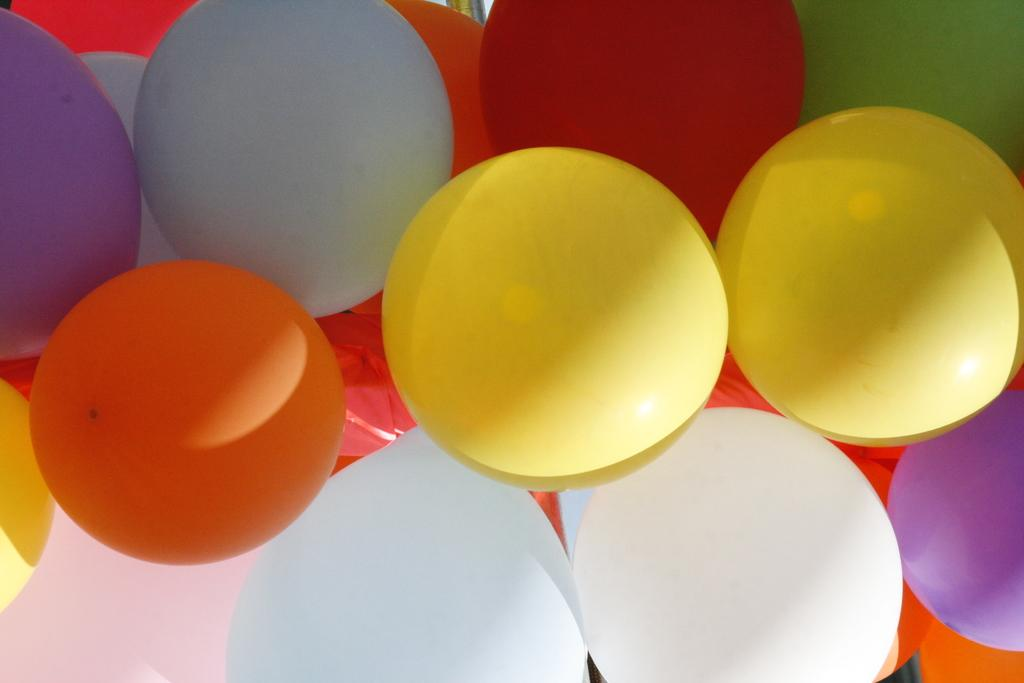What type of objects are in the image? There are colorful balloons in the image. How many chairs can be seen in the image? There are no chairs present in the image; it only features colorful balloons. What type of thing is attached to the balloons in the image? There is no thing attached to the balloons in the image. What type of rod is used to hold the balloons in the image? There is no rod used to hold the balloons in the image. 